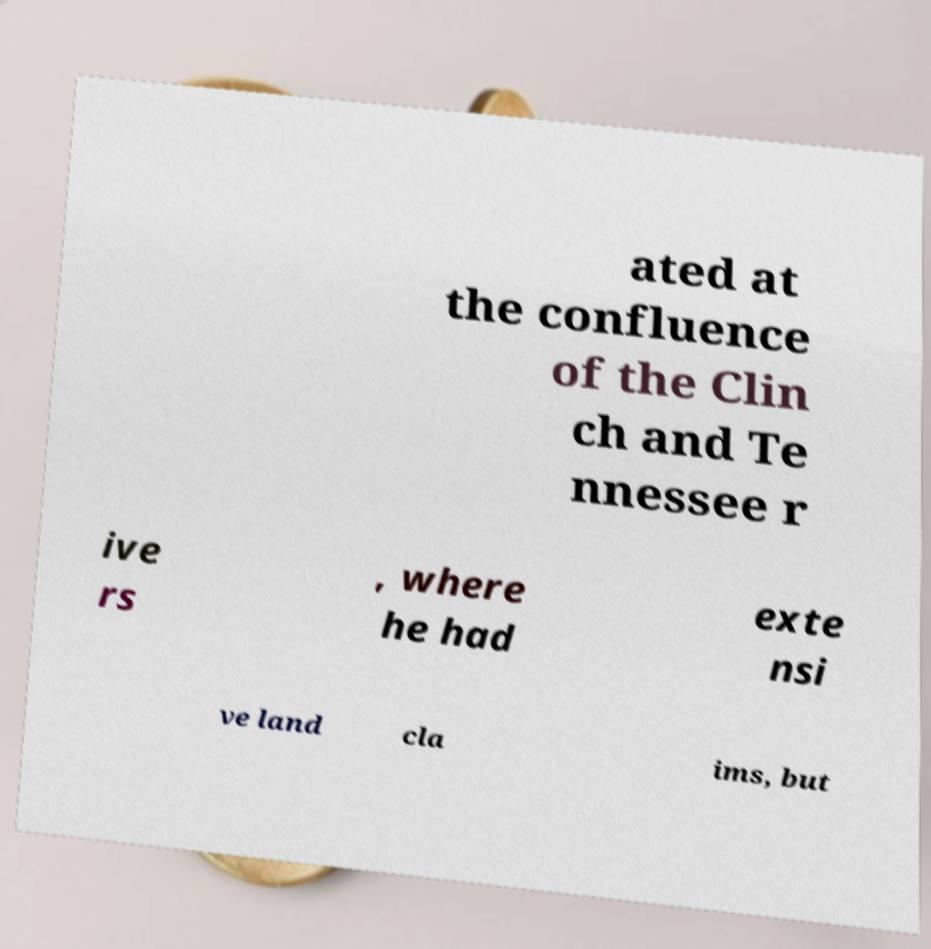I need the written content from this picture converted into text. Can you do that? ated at the confluence of the Clin ch and Te nnessee r ive rs , where he had exte nsi ve land cla ims, but 